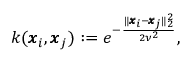<formula> <loc_0><loc_0><loc_500><loc_500>k ( \pm b { x } _ { i } , \pm b { x } _ { j } ) \colon = e ^ { - \frac { \| \pm b { x } _ { i } - \pm b { x } _ { j } \| _ { 2 } ^ { 2 } } { 2 \nu ^ { 2 } } } ,</formula> 